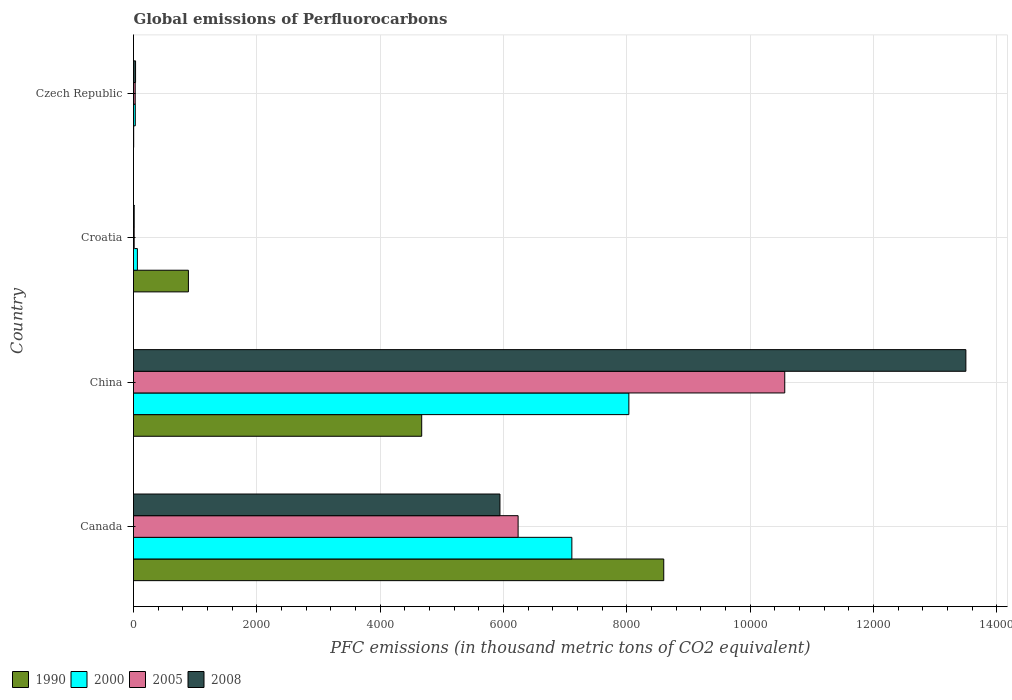How many groups of bars are there?
Your response must be concise. 4. How many bars are there on the 2nd tick from the top?
Ensure brevity in your answer.  4. What is the global emissions of Perfluorocarbons in 2005 in China?
Give a very brief answer. 1.06e+04. Across all countries, what is the maximum global emissions of Perfluorocarbons in 1990?
Provide a short and direct response. 8600.3. Across all countries, what is the minimum global emissions of Perfluorocarbons in 2000?
Provide a succinct answer. 28.8. In which country was the global emissions of Perfluorocarbons in 1990 maximum?
Keep it short and to the point. Canada. In which country was the global emissions of Perfluorocarbons in 1990 minimum?
Make the answer very short. Czech Republic. What is the total global emissions of Perfluorocarbons in 2008 in the graph?
Provide a succinct answer. 1.95e+04. What is the difference between the global emissions of Perfluorocarbons in 1990 in Croatia and that in Czech Republic?
Keep it short and to the point. 887.6. What is the difference between the global emissions of Perfluorocarbons in 1990 in Croatia and the global emissions of Perfluorocarbons in 2005 in Czech Republic?
Give a very brief answer. 862.9. What is the average global emissions of Perfluorocarbons in 2005 per country?
Your answer should be compact. 4209.8. What is the difference between the global emissions of Perfluorocarbons in 2000 and global emissions of Perfluorocarbons in 2008 in Czech Republic?
Ensure brevity in your answer.  -4.5. In how many countries, is the global emissions of Perfluorocarbons in 2008 greater than 8800 thousand metric tons?
Offer a very short reply. 1. What is the ratio of the global emissions of Perfluorocarbons in 2005 in China to that in Czech Republic?
Offer a terse response. 384.1. Is the difference between the global emissions of Perfluorocarbons in 2000 in China and Czech Republic greater than the difference between the global emissions of Perfluorocarbons in 2008 in China and Czech Republic?
Ensure brevity in your answer.  No. What is the difference between the highest and the second highest global emissions of Perfluorocarbons in 2000?
Give a very brief answer. 924.5. What is the difference between the highest and the lowest global emissions of Perfluorocarbons in 2008?
Your answer should be compact. 1.35e+04. Is the sum of the global emissions of Perfluorocarbons in 2000 in Canada and Czech Republic greater than the maximum global emissions of Perfluorocarbons in 1990 across all countries?
Give a very brief answer. No. Is it the case that in every country, the sum of the global emissions of Perfluorocarbons in 2008 and global emissions of Perfluorocarbons in 1990 is greater than the sum of global emissions of Perfluorocarbons in 2000 and global emissions of Perfluorocarbons in 2005?
Ensure brevity in your answer.  No. What does the 2nd bar from the bottom in Canada represents?
Provide a succinct answer. 2000. Are all the bars in the graph horizontal?
Your answer should be very brief. Yes. What is the difference between two consecutive major ticks on the X-axis?
Provide a short and direct response. 2000. Does the graph contain grids?
Give a very brief answer. Yes. How are the legend labels stacked?
Make the answer very short. Horizontal. What is the title of the graph?
Provide a succinct answer. Global emissions of Perfluorocarbons. Does "1990" appear as one of the legend labels in the graph?
Your response must be concise. Yes. What is the label or title of the X-axis?
Your response must be concise. PFC emissions (in thousand metric tons of CO2 equivalent). What is the label or title of the Y-axis?
Provide a succinct answer. Country. What is the PFC emissions (in thousand metric tons of CO2 equivalent) of 1990 in Canada?
Make the answer very short. 8600.3. What is the PFC emissions (in thousand metric tons of CO2 equivalent) of 2000 in Canada?
Your answer should be compact. 7109.9. What is the PFC emissions (in thousand metric tons of CO2 equivalent) in 2005 in Canada?
Ensure brevity in your answer.  6238. What is the PFC emissions (in thousand metric tons of CO2 equivalent) in 2008 in Canada?
Offer a terse response. 5943.7. What is the PFC emissions (in thousand metric tons of CO2 equivalent) of 1990 in China?
Make the answer very short. 4674.5. What is the PFC emissions (in thousand metric tons of CO2 equivalent) of 2000 in China?
Your answer should be compact. 8034.4. What is the PFC emissions (in thousand metric tons of CO2 equivalent) of 2005 in China?
Ensure brevity in your answer.  1.06e+04. What is the PFC emissions (in thousand metric tons of CO2 equivalent) of 2008 in China?
Offer a very short reply. 1.35e+04. What is the PFC emissions (in thousand metric tons of CO2 equivalent) of 1990 in Croatia?
Provide a succinct answer. 890.4. What is the PFC emissions (in thousand metric tons of CO2 equivalent) of 2000 in Czech Republic?
Your answer should be compact. 28.8. What is the PFC emissions (in thousand metric tons of CO2 equivalent) of 2005 in Czech Republic?
Offer a very short reply. 27.5. What is the PFC emissions (in thousand metric tons of CO2 equivalent) of 2008 in Czech Republic?
Offer a very short reply. 33.3. Across all countries, what is the maximum PFC emissions (in thousand metric tons of CO2 equivalent) in 1990?
Your answer should be very brief. 8600.3. Across all countries, what is the maximum PFC emissions (in thousand metric tons of CO2 equivalent) in 2000?
Your answer should be very brief. 8034.4. Across all countries, what is the maximum PFC emissions (in thousand metric tons of CO2 equivalent) of 2005?
Offer a very short reply. 1.06e+04. Across all countries, what is the maximum PFC emissions (in thousand metric tons of CO2 equivalent) in 2008?
Your answer should be compact. 1.35e+04. Across all countries, what is the minimum PFC emissions (in thousand metric tons of CO2 equivalent) in 2000?
Ensure brevity in your answer.  28.8. Across all countries, what is the minimum PFC emissions (in thousand metric tons of CO2 equivalent) in 2005?
Offer a terse response. 10.9. Across all countries, what is the minimum PFC emissions (in thousand metric tons of CO2 equivalent) of 2008?
Offer a terse response. 11. What is the total PFC emissions (in thousand metric tons of CO2 equivalent) in 1990 in the graph?
Ensure brevity in your answer.  1.42e+04. What is the total PFC emissions (in thousand metric tons of CO2 equivalent) of 2000 in the graph?
Offer a terse response. 1.52e+04. What is the total PFC emissions (in thousand metric tons of CO2 equivalent) in 2005 in the graph?
Give a very brief answer. 1.68e+04. What is the total PFC emissions (in thousand metric tons of CO2 equivalent) in 2008 in the graph?
Provide a short and direct response. 1.95e+04. What is the difference between the PFC emissions (in thousand metric tons of CO2 equivalent) of 1990 in Canada and that in China?
Provide a succinct answer. 3925.8. What is the difference between the PFC emissions (in thousand metric tons of CO2 equivalent) of 2000 in Canada and that in China?
Offer a terse response. -924.5. What is the difference between the PFC emissions (in thousand metric tons of CO2 equivalent) of 2005 in Canada and that in China?
Ensure brevity in your answer.  -4324.8. What is the difference between the PFC emissions (in thousand metric tons of CO2 equivalent) of 2008 in Canada and that in China?
Ensure brevity in your answer.  -7556.9. What is the difference between the PFC emissions (in thousand metric tons of CO2 equivalent) in 1990 in Canada and that in Croatia?
Provide a succinct answer. 7709.9. What is the difference between the PFC emissions (in thousand metric tons of CO2 equivalent) of 2000 in Canada and that in Croatia?
Your response must be concise. 7046.9. What is the difference between the PFC emissions (in thousand metric tons of CO2 equivalent) in 2005 in Canada and that in Croatia?
Keep it short and to the point. 6227.1. What is the difference between the PFC emissions (in thousand metric tons of CO2 equivalent) of 2008 in Canada and that in Croatia?
Provide a succinct answer. 5932.7. What is the difference between the PFC emissions (in thousand metric tons of CO2 equivalent) in 1990 in Canada and that in Czech Republic?
Provide a short and direct response. 8597.5. What is the difference between the PFC emissions (in thousand metric tons of CO2 equivalent) in 2000 in Canada and that in Czech Republic?
Keep it short and to the point. 7081.1. What is the difference between the PFC emissions (in thousand metric tons of CO2 equivalent) of 2005 in Canada and that in Czech Republic?
Provide a short and direct response. 6210.5. What is the difference between the PFC emissions (in thousand metric tons of CO2 equivalent) of 2008 in Canada and that in Czech Republic?
Provide a short and direct response. 5910.4. What is the difference between the PFC emissions (in thousand metric tons of CO2 equivalent) of 1990 in China and that in Croatia?
Make the answer very short. 3784.1. What is the difference between the PFC emissions (in thousand metric tons of CO2 equivalent) of 2000 in China and that in Croatia?
Your response must be concise. 7971.4. What is the difference between the PFC emissions (in thousand metric tons of CO2 equivalent) in 2005 in China and that in Croatia?
Provide a short and direct response. 1.06e+04. What is the difference between the PFC emissions (in thousand metric tons of CO2 equivalent) in 2008 in China and that in Croatia?
Offer a terse response. 1.35e+04. What is the difference between the PFC emissions (in thousand metric tons of CO2 equivalent) of 1990 in China and that in Czech Republic?
Make the answer very short. 4671.7. What is the difference between the PFC emissions (in thousand metric tons of CO2 equivalent) in 2000 in China and that in Czech Republic?
Keep it short and to the point. 8005.6. What is the difference between the PFC emissions (in thousand metric tons of CO2 equivalent) of 2005 in China and that in Czech Republic?
Your answer should be very brief. 1.05e+04. What is the difference between the PFC emissions (in thousand metric tons of CO2 equivalent) in 2008 in China and that in Czech Republic?
Give a very brief answer. 1.35e+04. What is the difference between the PFC emissions (in thousand metric tons of CO2 equivalent) in 1990 in Croatia and that in Czech Republic?
Keep it short and to the point. 887.6. What is the difference between the PFC emissions (in thousand metric tons of CO2 equivalent) of 2000 in Croatia and that in Czech Republic?
Give a very brief answer. 34.2. What is the difference between the PFC emissions (in thousand metric tons of CO2 equivalent) in 2005 in Croatia and that in Czech Republic?
Ensure brevity in your answer.  -16.6. What is the difference between the PFC emissions (in thousand metric tons of CO2 equivalent) of 2008 in Croatia and that in Czech Republic?
Offer a terse response. -22.3. What is the difference between the PFC emissions (in thousand metric tons of CO2 equivalent) of 1990 in Canada and the PFC emissions (in thousand metric tons of CO2 equivalent) of 2000 in China?
Provide a succinct answer. 565.9. What is the difference between the PFC emissions (in thousand metric tons of CO2 equivalent) of 1990 in Canada and the PFC emissions (in thousand metric tons of CO2 equivalent) of 2005 in China?
Offer a very short reply. -1962.5. What is the difference between the PFC emissions (in thousand metric tons of CO2 equivalent) in 1990 in Canada and the PFC emissions (in thousand metric tons of CO2 equivalent) in 2008 in China?
Your answer should be very brief. -4900.3. What is the difference between the PFC emissions (in thousand metric tons of CO2 equivalent) of 2000 in Canada and the PFC emissions (in thousand metric tons of CO2 equivalent) of 2005 in China?
Offer a terse response. -3452.9. What is the difference between the PFC emissions (in thousand metric tons of CO2 equivalent) of 2000 in Canada and the PFC emissions (in thousand metric tons of CO2 equivalent) of 2008 in China?
Your answer should be very brief. -6390.7. What is the difference between the PFC emissions (in thousand metric tons of CO2 equivalent) of 2005 in Canada and the PFC emissions (in thousand metric tons of CO2 equivalent) of 2008 in China?
Keep it short and to the point. -7262.6. What is the difference between the PFC emissions (in thousand metric tons of CO2 equivalent) in 1990 in Canada and the PFC emissions (in thousand metric tons of CO2 equivalent) in 2000 in Croatia?
Keep it short and to the point. 8537.3. What is the difference between the PFC emissions (in thousand metric tons of CO2 equivalent) in 1990 in Canada and the PFC emissions (in thousand metric tons of CO2 equivalent) in 2005 in Croatia?
Ensure brevity in your answer.  8589.4. What is the difference between the PFC emissions (in thousand metric tons of CO2 equivalent) in 1990 in Canada and the PFC emissions (in thousand metric tons of CO2 equivalent) in 2008 in Croatia?
Keep it short and to the point. 8589.3. What is the difference between the PFC emissions (in thousand metric tons of CO2 equivalent) of 2000 in Canada and the PFC emissions (in thousand metric tons of CO2 equivalent) of 2005 in Croatia?
Provide a short and direct response. 7099. What is the difference between the PFC emissions (in thousand metric tons of CO2 equivalent) in 2000 in Canada and the PFC emissions (in thousand metric tons of CO2 equivalent) in 2008 in Croatia?
Keep it short and to the point. 7098.9. What is the difference between the PFC emissions (in thousand metric tons of CO2 equivalent) in 2005 in Canada and the PFC emissions (in thousand metric tons of CO2 equivalent) in 2008 in Croatia?
Provide a succinct answer. 6227. What is the difference between the PFC emissions (in thousand metric tons of CO2 equivalent) in 1990 in Canada and the PFC emissions (in thousand metric tons of CO2 equivalent) in 2000 in Czech Republic?
Give a very brief answer. 8571.5. What is the difference between the PFC emissions (in thousand metric tons of CO2 equivalent) of 1990 in Canada and the PFC emissions (in thousand metric tons of CO2 equivalent) of 2005 in Czech Republic?
Ensure brevity in your answer.  8572.8. What is the difference between the PFC emissions (in thousand metric tons of CO2 equivalent) of 1990 in Canada and the PFC emissions (in thousand metric tons of CO2 equivalent) of 2008 in Czech Republic?
Keep it short and to the point. 8567. What is the difference between the PFC emissions (in thousand metric tons of CO2 equivalent) in 2000 in Canada and the PFC emissions (in thousand metric tons of CO2 equivalent) in 2005 in Czech Republic?
Make the answer very short. 7082.4. What is the difference between the PFC emissions (in thousand metric tons of CO2 equivalent) in 2000 in Canada and the PFC emissions (in thousand metric tons of CO2 equivalent) in 2008 in Czech Republic?
Your response must be concise. 7076.6. What is the difference between the PFC emissions (in thousand metric tons of CO2 equivalent) of 2005 in Canada and the PFC emissions (in thousand metric tons of CO2 equivalent) of 2008 in Czech Republic?
Ensure brevity in your answer.  6204.7. What is the difference between the PFC emissions (in thousand metric tons of CO2 equivalent) of 1990 in China and the PFC emissions (in thousand metric tons of CO2 equivalent) of 2000 in Croatia?
Offer a terse response. 4611.5. What is the difference between the PFC emissions (in thousand metric tons of CO2 equivalent) in 1990 in China and the PFC emissions (in thousand metric tons of CO2 equivalent) in 2005 in Croatia?
Make the answer very short. 4663.6. What is the difference between the PFC emissions (in thousand metric tons of CO2 equivalent) in 1990 in China and the PFC emissions (in thousand metric tons of CO2 equivalent) in 2008 in Croatia?
Keep it short and to the point. 4663.5. What is the difference between the PFC emissions (in thousand metric tons of CO2 equivalent) of 2000 in China and the PFC emissions (in thousand metric tons of CO2 equivalent) of 2005 in Croatia?
Provide a short and direct response. 8023.5. What is the difference between the PFC emissions (in thousand metric tons of CO2 equivalent) in 2000 in China and the PFC emissions (in thousand metric tons of CO2 equivalent) in 2008 in Croatia?
Keep it short and to the point. 8023.4. What is the difference between the PFC emissions (in thousand metric tons of CO2 equivalent) in 2005 in China and the PFC emissions (in thousand metric tons of CO2 equivalent) in 2008 in Croatia?
Provide a short and direct response. 1.06e+04. What is the difference between the PFC emissions (in thousand metric tons of CO2 equivalent) of 1990 in China and the PFC emissions (in thousand metric tons of CO2 equivalent) of 2000 in Czech Republic?
Make the answer very short. 4645.7. What is the difference between the PFC emissions (in thousand metric tons of CO2 equivalent) in 1990 in China and the PFC emissions (in thousand metric tons of CO2 equivalent) in 2005 in Czech Republic?
Provide a succinct answer. 4647. What is the difference between the PFC emissions (in thousand metric tons of CO2 equivalent) of 1990 in China and the PFC emissions (in thousand metric tons of CO2 equivalent) of 2008 in Czech Republic?
Your response must be concise. 4641.2. What is the difference between the PFC emissions (in thousand metric tons of CO2 equivalent) of 2000 in China and the PFC emissions (in thousand metric tons of CO2 equivalent) of 2005 in Czech Republic?
Your response must be concise. 8006.9. What is the difference between the PFC emissions (in thousand metric tons of CO2 equivalent) in 2000 in China and the PFC emissions (in thousand metric tons of CO2 equivalent) in 2008 in Czech Republic?
Provide a short and direct response. 8001.1. What is the difference between the PFC emissions (in thousand metric tons of CO2 equivalent) in 2005 in China and the PFC emissions (in thousand metric tons of CO2 equivalent) in 2008 in Czech Republic?
Give a very brief answer. 1.05e+04. What is the difference between the PFC emissions (in thousand metric tons of CO2 equivalent) in 1990 in Croatia and the PFC emissions (in thousand metric tons of CO2 equivalent) in 2000 in Czech Republic?
Offer a terse response. 861.6. What is the difference between the PFC emissions (in thousand metric tons of CO2 equivalent) in 1990 in Croatia and the PFC emissions (in thousand metric tons of CO2 equivalent) in 2005 in Czech Republic?
Ensure brevity in your answer.  862.9. What is the difference between the PFC emissions (in thousand metric tons of CO2 equivalent) of 1990 in Croatia and the PFC emissions (in thousand metric tons of CO2 equivalent) of 2008 in Czech Republic?
Make the answer very short. 857.1. What is the difference between the PFC emissions (in thousand metric tons of CO2 equivalent) of 2000 in Croatia and the PFC emissions (in thousand metric tons of CO2 equivalent) of 2005 in Czech Republic?
Offer a terse response. 35.5. What is the difference between the PFC emissions (in thousand metric tons of CO2 equivalent) of 2000 in Croatia and the PFC emissions (in thousand metric tons of CO2 equivalent) of 2008 in Czech Republic?
Your answer should be very brief. 29.7. What is the difference between the PFC emissions (in thousand metric tons of CO2 equivalent) in 2005 in Croatia and the PFC emissions (in thousand metric tons of CO2 equivalent) in 2008 in Czech Republic?
Give a very brief answer. -22.4. What is the average PFC emissions (in thousand metric tons of CO2 equivalent) in 1990 per country?
Give a very brief answer. 3542. What is the average PFC emissions (in thousand metric tons of CO2 equivalent) in 2000 per country?
Give a very brief answer. 3809.03. What is the average PFC emissions (in thousand metric tons of CO2 equivalent) of 2005 per country?
Provide a short and direct response. 4209.8. What is the average PFC emissions (in thousand metric tons of CO2 equivalent) in 2008 per country?
Keep it short and to the point. 4872.15. What is the difference between the PFC emissions (in thousand metric tons of CO2 equivalent) in 1990 and PFC emissions (in thousand metric tons of CO2 equivalent) in 2000 in Canada?
Provide a succinct answer. 1490.4. What is the difference between the PFC emissions (in thousand metric tons of CO2 equivalent) of 1990 and PFC emissions (in thousand metric tons of CO2 equivalent) of 2005 in Canada?
Your answer should be compact. 2362.3. What is the difference between the PFC emissions (in thousand metric tons of CO2 equivalent) in 1990 and PFC emissions (in thousand metric tons of CO2 equivalent) in 2008 in Canada?
Provide a short and direct response. 2656.6. What is the difference between the PFC emissions (in thousand metric tons of CO2 equivalent) of 2000 and PFC emissions (in thousand metric tons of CO2 equivalent) of 2005 in Canada?
Your answer should be very brief. 871.9. What is the difference between the PFC emissions (in thousand metric tons of CO2 equivalent) in 2000 and PFC emissions (in thousand metric tons of CO2 equivalent) in 2008 in Canada?
Your response must be concise. 1166.2. What is the difference between the PFC emissions (in thousand metric tons of CO2 equivalent) of 2005 and PFC emissions (in thousand metric tons of CO2 equivalent) of 2008 in Canada?
Provide a short and direct response. 294.3. What is the difference between the PFC emissions (in thousand metric tons of CO2 equivalent) of 1990 and PFC emissions (in thousand metric tons of CO2 equivalent) of 2000 in China?
Give a very brief answer. -3359.9. What is the difference between the PFC emissions (in thousand metric tons of CO2 equivalent) in 1990 and PFC emissions (in thousand metric tons of CO2 equivalent) in 2005 in China?
Provide a short and direct response. -5888.3. What is the difference between the PFC emissions (in thousand metric tons of CO2 equivalent) in 1990 and PFC emissions (in thousand metric tons of CO2 equivalent) in 2008 in China?
Make the answer very short. -8826.1. What is the difference between the PFC emissions (in thousand metric tons of CO2 equivalent) of 2000 and PFC emissions (in thousand metric tons of CO2 equivalent) of 2005 in China?
Provide a succinct answer. -2528.4. What is the difference between the PFC emissions (in thousand metric tons of CO2 equivalent) of 2000 and PFC emissions (in thousand metric tons of CO2 equivalent) of 2008 in China?
Your answer should be compact. -5466.2. What is the difference between the PFC emissions (in thousand metric tons of CO2 equivalent) of 2005 and PFC emissions (in thousand metric tons of CO2 equivalent) of 2008 in China?
Give a very brief answer. -2937.8. What is the difference between the PFC emissions (in thousand metric tons of CO2 equivalent) in 1990 and PFC emissions (in thousand metric tons of CO2 equivalent) in 2000 in Croatia?
Make the answer very short. 827.4. What is the difference between the PFC emissions (in thousand metric tons of CO2 equivalent) of 1990 and PFC emissions (in thousand metric tons of CO2 equivalent) of 2005 in Croatia?
Your answer should be compact. 879.5. What is the difference between the PFC emissions (in thousand metric tons of CO2 equivalent) of 1990 and PFC emissions (in thousand metric tons of CO2 equivalent) of 2008 in Croatia?
Provide a succinct answer. 879.4. What is the difference between the PFC emissions (in thousand metric tons of CO2 equivalent) in 2000 and PFC emissions (in thousand metric tons of CO2 equivalent) in 2005 in Croatia?
Keep it short and to the point. 52.1. What is the difference between the PFC emissions (in thousand metric tons of CO2 equivalent) in 2000 and PFC emissions (in thousand metric tons of CO2 equivalent) in 2008 in Croatia?
Make the answer very short. 52. What is the difference between the PFC emissions (in thousand metric tons of CO2 equivalent) of 1990 and PFC emissions (in thousand metric tons of CO2 equivalent) of 2000 in Czech Republic?
Your answer should be very brief. -26. What is the difference between the PFC emissions (in thousand metric tons of CO2 equivalent) of 1990 and PFC emissions (in thousand metric tons of CO2 equivalent) of 2005 in Czech Republic?
Make the answer very short. -24.7. What is the difference between the PFC emissions (in thousand metric tons of CO2 equivalent) of 1990 and PFC emissions (in thousand metric tons of CO2 equivalent) of 2008 in Czech Republic?
Ensure brevity in your answer.  -30.5. What is the difference between the PFC emissions (in thousand metric tons of CO2 equivalent) in 2000 and PFC emissions (in thousand metric tons of CO2 equivalent) in 2008 in Czech Republic?
Give a very brief answer. -4.5. What is the difference between the PFC emissions (in thousand metric tons of CO2 equivalent) in 2005 and PFC emissions (in thousand metric tons of CO2 equivalent) in 2008 in Czech Republic?
Provide a short and direct response. -5.8. What is the ratio of the PFC emissions (in thousand metric tons of CO2 equivalent) in 1990 in Canada to that in China?
Offer a very short reply. 1.84. What is the ratio of the PFC emissions (in thousand metric tons of CO2 equivalent) in 2000 in Canada to that in China?
Keep it short and to the point. 0.88. What is the ratio of the PFC emissions (in thousand metric tons of CO2 equivalent) of 2005 in Canada to that in China?
Offer a terse response. 0.59. What is the ratio of the PFC emissions (in thousand metric tons of CO2 equivalent) in 2008 in Canada to that in China?
Offer a very short reply. 0.44. What is the ratio of the PFC emissions (in thousand metric tons of CO2 equivalent) in 1990 in Canada to that in Croatia?
Ensure brevity in your answer.  9.66. What is the ratio of the PFC emissions (in thousand metric tons of CO2 equivalent) in 2000 in Canada to that in Croatia?
Provide a succinct answer. 112.86. What is the ratio of the PFC emissions (in thousand metric tons of CO2 equivalent) in 2005 in Canada to that in Croatia?
Your answer should be very brief. 572.29. What is the ratio of the PFC emissions (in thousand metric tons of CO2 equivalent) of 2008 in Canada to that in Croatia?
Offer a very short reply. 540.34. What is the ratio of the PFC emissions (in thousand metric tons of CO2 equivalent) in 1990 in Canada to that in Czech Republic?
Make the answer very short. 3071.54. What is the ratio of the PFC emissions (in thousand metric tons of CO2 equivalent) in 2000 in Canada to that in Czech Republic?
Keep it short and to the point. 246.87. What is the ratio of the PFC emissions (in thousand metric tons of CO2 equivalent) in 2005 in Canada to that in Czech Republic?
Your response must be concise. 226.84. What is the ratio of the PFC emissions (in thousand metric tons of CO2 equivalent) in 2008 in Canada to that in Czech Republic?
Your answer should be very brief. 178.49. What is the ratio of the PFC emissions (in thousand metric tons of CO2 equivalent) of 1990 in China to that in Croatia?
Your answer should be compact. 5.25. What is the ratio of the PFC emissions (in thousand metric tons of CO2 equivalent) in 2000 in China to that in Croatia?
Provide a succinct answer. 127.53. What is the ratio of the PFC emissions (in thousand metric tons of CO2 equivalent) of 2005 in China to that in Croatia?
Offer a very short reply. 969.06. What is the ratio of the PFC emissions (in thousand metric tons of CO2 equivalent) of 2008 in China to that in Croatia?
Your answer should be compact. 1227.33. What is the ratio of the PFC emissions (in thousand metric tons of CO2 equivalent) of 1990 in China to that in Czech Republic?
Ensure brevity in your answer.  1669.46. What is the ratio of the PFC emissions (in thousand metric tons of CO2 equivalent) of 2000 in China to that in Czech Republic?
Give a very brief answer. 278.97. What is the ratio of the PFC emissions (in thousand metric tons of CO2 equivalent) in 2005 in China to that in Czech Republic?
Keep it short and to the point. 384.1. What is the ratio of the PFC emissions (in thousand metric tons of CO2 equivalent) in 2008 in China to that in Czech Republic?
Your response must be concise. 405.42. What is the ratio of the PFC emissions (in thousand metric tons of CO2 equivalent) in 1990 in Croatia to that in Czech Republic?
Offer a very short reply. 318. What is the ratio of the PFC emissions (in thousand metric tons of CO2 equivalent) of 2000 in Croatia to that in Czech Republic?
Give a very brief answer. 2.19. What is the ratio of the PFC emissions (in thousand metric tons of CO2 equivalent) in 2005 in Croatia to that in Czech Republic?
Your answer should be compact. 0.4. What is the ratio of the PFC emissions (in thousand metric tons of CO2 equivalent) of 2008 in Croatia to that in Czech Republic?
Your answer should be very brief. 0.33. What is the difference between the highest and the second highest PFC emissions (in thousand metric tons of CO2 equivalent) of 1990?
Ensure brevity in your answer.  3925.8. What is the difference between the highest and the second highest PFC emissions (in thousand metric tons of CO2 equivalent) in 2000?
Keep it short and to the point. 924.5. What is the difference between the highest and the second highest PFC emissions (in thousand metric tons of CO2 equivalent) of 2005?
Your answer should be compact. 4324.8. What is the difference between the highest and the second highest PFC emissions (in thousand metric tons of CO2 equivalent) of 2008?
Make the answer very short. 7556.9. What is the difference between the highest and the lowest PFC emissions (in thousand metric tons of CO2 equivalent) in 1990?
Your answer should be compact. 8597.5. What is the difference between the highest and the lowest PFC emissions (in thousand metric tons of CO2 equivalent) of 2000?
Keep it short and to the point. 8005.6. What is the difference between the highest and the lowest PFC emissions (in thousand metric tons of CO2 equivalent) in 2005?
Provide a succinct answer. 1.06e+04. What is the difference between the highest and the lowest PFC emissions (in thousand metric tons of CO2 equivalent) of 2008?
Offer a very short reply. 1.35e+04. 